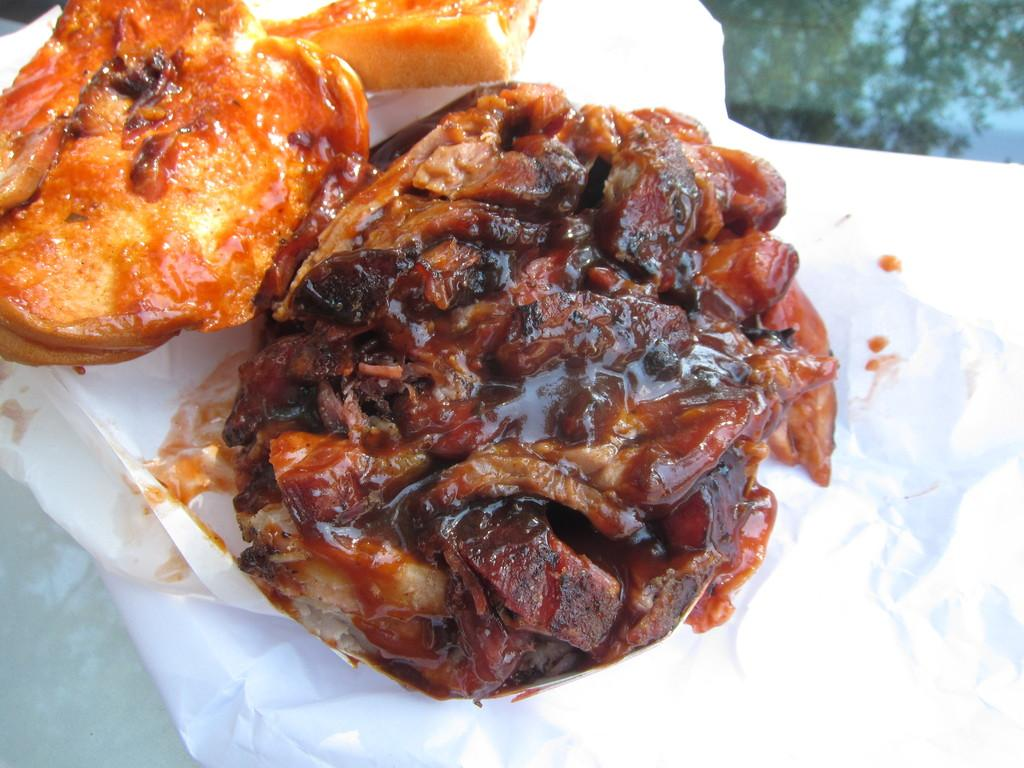What is the main object in the image? There is a dish in the image. What other item can be seen in the image? There is a white color paper in the image. What stage is the dish being used on in the image? There is no stage present in the image, and the use of the dish cannot be determined from the image alone. 